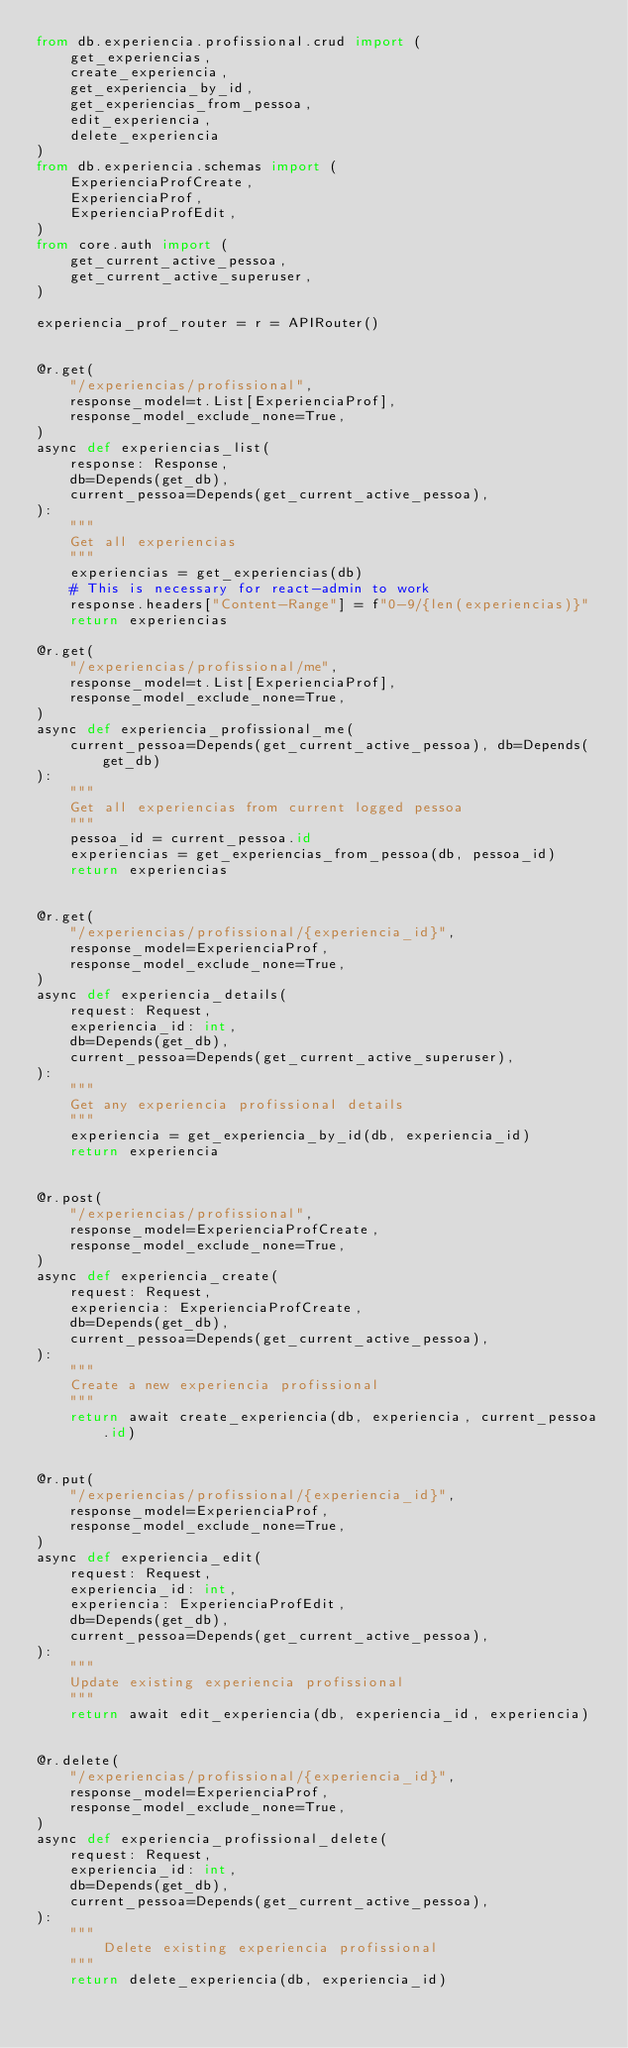Convert code to text. <code><loc_0><loc_0><loc_500><loc_500><_Python_>from db.experiencia.profissional.crud import (
    get_experiencias,
    create_experiencia,
    get_experiencia_by_id,
    get_experiencias_from_pessoa,
    edit_experiencia,
    delete_experiencia
)
from db.experiencia.schemas import (
    ExperienciaProfCreate,
    ExperienciaProf,
    ExperienciaProfEdit,
)
from core.auth import (
    get_current_active_pessoa,
    get_current_active_superuser,
)

experiencia_prof_router = r = APIRouter()


@r.get(
    "/experiencias/profissional",
    response_model=t.List[ExperienciaProf],
    response_model_exclude_none=True,
)
async def experiencias_list(
    response: Response,
    db=Depends(get_db),
    current_pessoa=Depends(get_current_active_pessoa),
):
    """
    Get all experiencias
    """
    experiencias = get_experiencias(db)
    # This is necessary for react-admin to work
    response.headers["Content-Range"] = f"0-9/{len(experiencias)}"
    return experiencias

@r.get(
    "/experiencias/profissional/me",
    response_model=t.List[ExperienciaProf],
    response_model_exclude_none=True,
)
async def experiencia_profissional_me(
    current_pessoa=Depends(get_current_active_pessoa), db=Depends(get_db)
):
    """
    Get all experiencias from current logged pessoa
    """
    pessoa_id = current_pessoa.id
    experiencias = get_experiencias_from_pessoa(db, pessoa_id)
    return experiencias


@r.get(
    "/experiencias/profissional/{experiencia_id}",
    response_model=ExperienciaProf,
    response_model_exclude_none=True,
)
async def experiencia_details(
    request: Request,
    experiencia_id: int,
    db=Depends(get_db),
    current_pessoa=Depends(get_current_active_superuser),
):
    """
    Get any experiencia profissional details
    """
    experiencia = get_experiencia_by_id(db, experiencia_id)
    return experiencia


@r.post(
    "/experiencias/profissional",
    response_model=ExperienciaProfCreate,
    response_model_exclude_none=True,
)
async def experiencia_create(
    request: Request,
    experiencia: ExperienciaProfCreate,
    db=Depends(get_db),
    current_pessoa=Depends(get_current_active_pessoa),
):
    """
    Create a new experiencia profissional
    """
    return await create_experiencia(db, experiencia, current_pessoa.id)


@r.put(
    "/experiencias/profissional/{experiencia_id}",
    response_model=ExperienciaProf,
    response_model_exclude_none=True,
)
async def experiencia_edit(
    request: Request,
    experiencia_id: int,
    experiencia: ExperienciaProfEdit,
    db=Depends(get_db),
    current_pessoa=Depends(get_current_active_pessoa),
):
    """
    Update existing experiencia profissional
    """
    return await edit_experiencia(db, experiencia_id, experiencia)


@r.delete(
    "/experiencias/profissional/{experiencia_id}",
    response_model=ExperienciaProf,
    response_model_exclude_none=True,
)
async def experiencia_profissional_delete(
    request: Request,
    experiencia_id: int,
    db=Depends(get_db),
    current_pessoa=Depends(get_current_active_pessoa),
):
    """
        Delete existing experiencia profissional
    """
    return delete_experiencia(db, experiencia_id)
</code> 